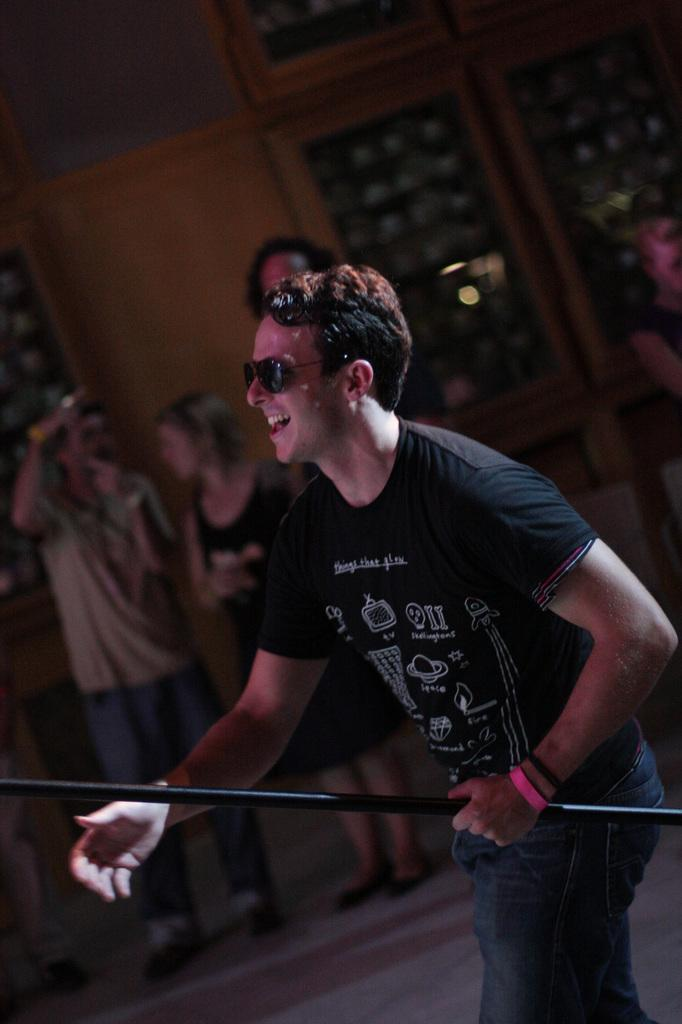What is the main subject of the image? There is a man standing in the center of the image. What is the man holding in his hand? The man is holding a rod in his hand. Can you describe the background of the image? There are people in the background of the image, and there is a wall visible. What type of power is the man generating with the rod in the image? There is no indication in the image that the man is generating any power with the rod. 